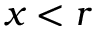<formula> <loc_0><loc_0><loc_500><loc_500>x < r</formula> 